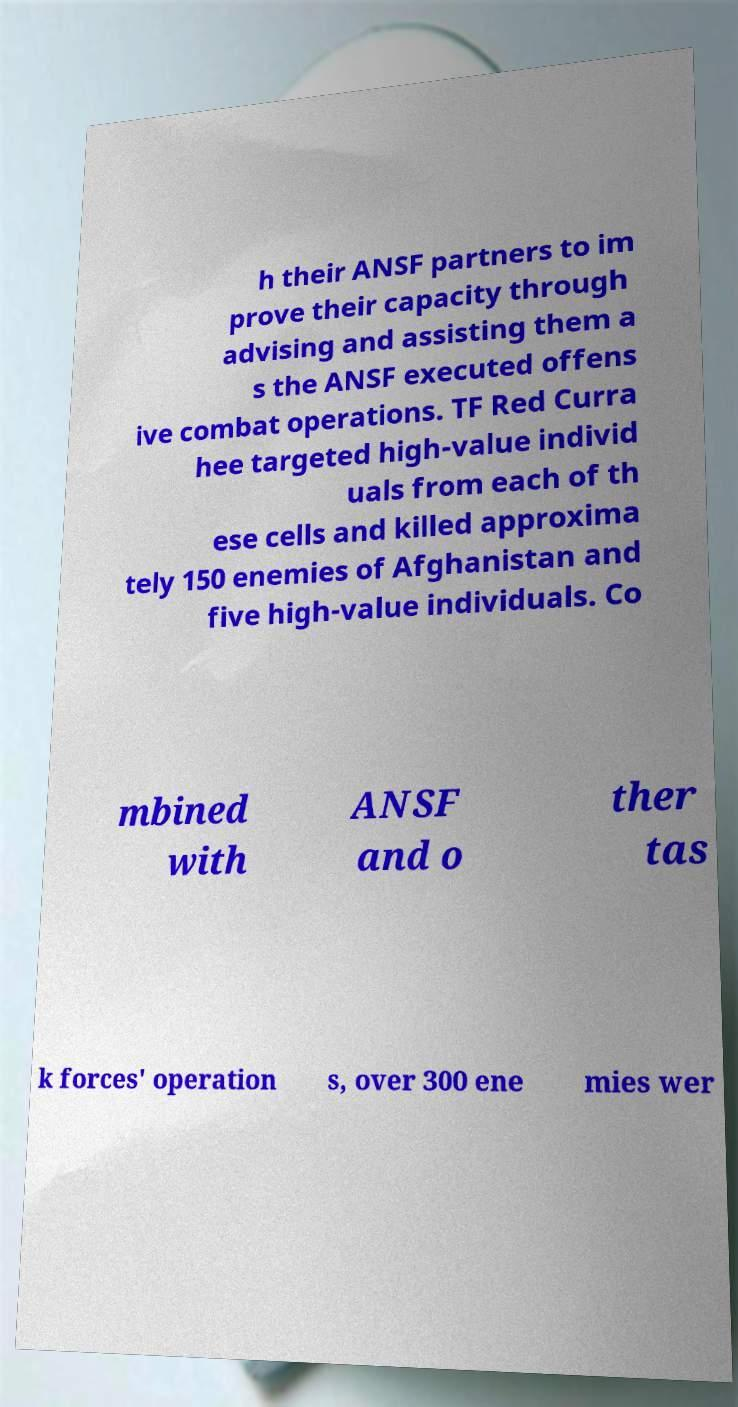Could you extract and type out the text from this image? h their ANSF partners to im prove their capacity through advising and assisting them a s the ANSF executed offens ive combat operations. TF Red Curra hee targeted high-value individ uals from each of th ese cells and killed approxima tely 150 enemies of Afghanistan and five high-value individuals. Co mbined with ANSF and o ther tas k forces' operation s, over 300 ene mies wer 